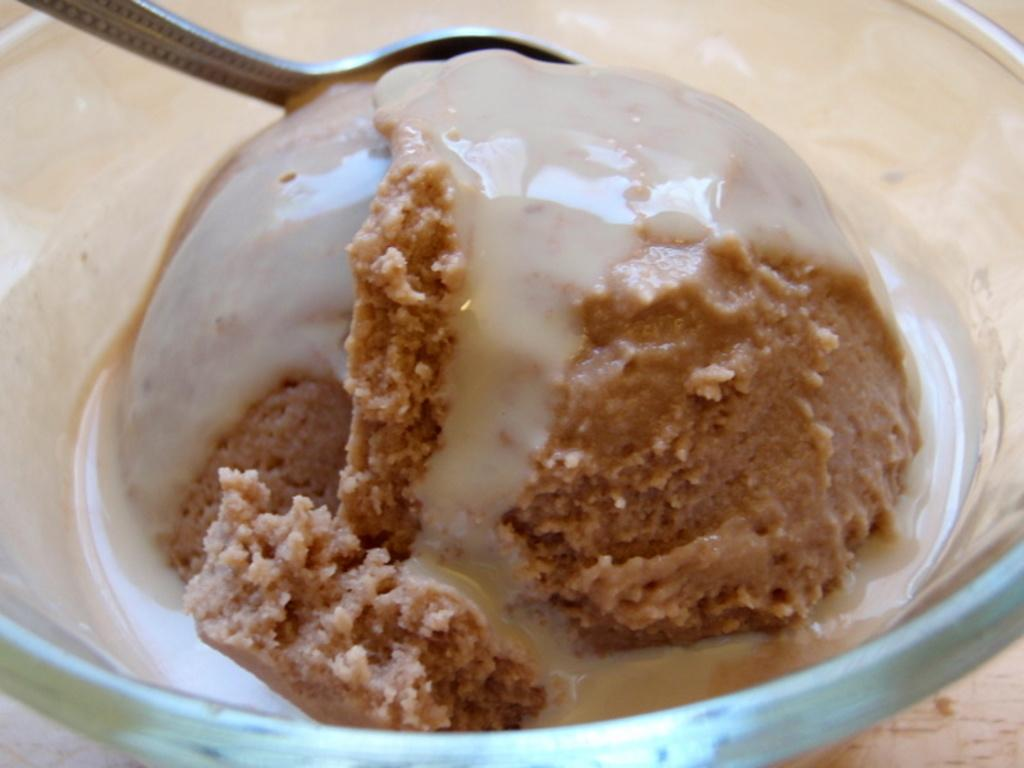What type of food is visible in the image? The image contains food, but the specific type cannot be determined from the provided facts. What utensil is present in the image? There is a spoon in the image. What is the food contained in? The food is contained in a bowl in the image. What type of crib is visible in the image? There is no crib present in the image; it features food, a spoon, and a bowl. What request is being made by the food in the image? The food in the image is not making any requests, as it is an inanimate object. 